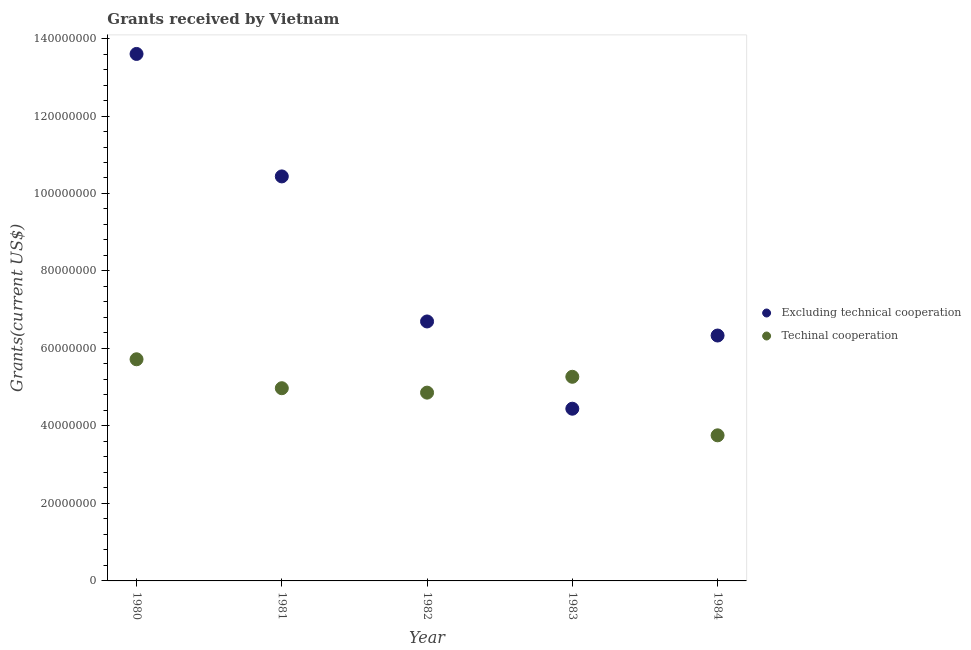Is the number of dotlines equal to the number of legend labels?
Your response must be concise. Yes. What is the amount of grants received(including technical cooperation) in 1983?
Provide a short and direct response. 5.27e+07. Across all years, what is the maximum amount of grants received(including technical cooperation)?
Ensure brevity in your answer.  5.72e+07. Across all years, what is the minimum amount of grants received(including technical cooperation)?
Make the answer very short. 3.76e+07. In which year was the amount of grants received(including technical cooperation) minimum?
Ensure brevity in your answer.  1984. What is the total amount of grants received(including technical cooperation) in the graph?
Keep it short and to the point. 2.46e+08. What is the difference between the amount of grants received(including technical cooperation) in 1981 and that in 1984?
Provide a succinct answer. 1.22e+07. What is the difference between the amount of grants received(including technical cooperation) in 1980 and the amount of grants received(excluding technical cooperation) in 1984?
Ensure brevity in your answer.  -6.13e+06. What is the average amount of grants received(including technical cooperation) per year?
Give a very brief answer. 4.92e+07. In the year 1982, what is the difference between the amount of grants received(including technical cooperation) and amount of grants received(excluding technical cooperation)?
Your answer should be very brief. -1.84e+07. What is the ratio of the amount of grants received(excluding technical cooperation) in 1981 to that in 1984?
Make the answer very short. 1.65. Is the amount of grants received(excluding technical cooperation) in 1980 less than that in 1983?
Offer a terse response. No. Is the difference between the amount of grants received(excluding technical cooperation) in 1982 and 1984 greater than the difference between the amount of grants received(including technical cooperation) in 1982 and 1984?
Your response must be concise. No. What is the difference between the highest and the second highest amount of grants received(excluding technical cooperation)?
Your answer should be very brief. 3.16e+07. What is the difference between the highest and the lowest amount of grants received(including technical cooperation)?
Offer a terse response. 1.96e+07. In how many years, is the amount of grants received(excluding technical cooperation) greater than the average amount of grants received(excluding technical cooperation) taken over all years?
Ensure brevity in your answer.  2. Is the sum of the amount of grants received(excluding technical cooperation) in 1982 and 1983 greater than the maximum amount of grants received(including technical cooperation) across all years?
Your response must be concise. Yes. How many years are there in the graph?
Offer a very short reply. 5. Does the graph contain any zero values?
Provide a succinct answer. No. Does the graph contain grids?
Keep it short and to the point. No. Where does the legend appear in the graph?
Make the answer very short. Center right. How many legend labels are there?
Keep it short and to the point. 2. How are the legend labels stacked?
Keep it short and to the point. Vertical. What is the title of the graph?
Give a very brief answer. Grants received by Vietnam. Does "Overweight" appear as one of the legend labels in the graph?
Ensure brevity in your answer.  No. What is the label or title of the Y-axis?
Provide a short and direct response. Grants(current US$). What is the Grants(current US$) of Excluding technical cooperation in 1980?
Provide a succinct answer. 1.36e+08. What is the Grants(current US$) in Techinal cooperation in 1980?
Offer a very short reply. 5.72e+07. What is the Grants(current US$) of Excluding technical cooperation in 1981?
Give a very brief answer. 1.04e+08. What is the Grants(current US$) of Techinal cooperation in 1981?
Your answer should be very brief. 4.97e+07. What is the Grants(current US$) in Excluding technical cooperation in 1982?
Your answer should be compact. 6.70e+07. What is the Grants(current US$) in Techinal cooperation in 1982?
Ensure brevity in your answer.  4.86e+07. What is the Grants(current US$) in Excluding technical cooperation in 1983?
Make the answer very short. 4.44e+07. What is the Grants(current US$) of Techinal cooperation in 1983?
Offer a terse response. 5.27e+07. What is the Grants(current US$) in Excluding technical cooperation in 1984?
Your answer should be compact. 6.33e+07. What is the Grants(current US$) of Techinal cooperation in 1984?
Keep it short and to the point. 3.76e+07. Across all years, what is the maximum Grants(current US$) of Excluding technical cooperation?
Offer a very short reply. 1.36e+08. Across all years, what is the maximum Grants(current US$) of Techinal cooperation?
Ensure brevity in your answer.  5.72e+07. Across all years, what is the minimum Grants(current US$) of Excluding technical cooperation?
Keep it short and to the point. 4.44e+07. Across all years, what is the minimum Grants(current US$) of Techinal cooperation?
Make the answer very short. 3.76e+07. What is the total Grants(current US$) of Excluding technical cooperation in the graph?
Give a very brief answer. 4.15e+08. What is the total Grants(current US$) of Techinal cooperation in the graph?
Offer a very short reply. 2.46e+08. What is the difference between the Grants(current US$) in Excluding technical cooperation in 1980 and that in 1981?
Offer a very short reply. 3.16e+07. What is the difference between the Grants(current US$) in Techinal cooperation in 1980 and that in 1981?
Ensure brevity in your answer.  7.47e+06. What is the difference between the Grants(current US$) of Excluding technical cooperation in 1980 and that in 1982?
Give a very brief answer. 6.90e+07. What is the difference between the Grants(current US$) of Techinal cooperation in 1980 and that in 1982?
Your answer should be very brief. 8.61e+06. What is the difference between the Grants(current US$) in Excluding technical cooperation in 1980 and that in 1983?
Offer a very short reply. 9.16e+07. What is the difference between the Grants(current US$) of Techinal cooperation in 1980 and that in 1983?
Your response must be concise. 4.52e+06. What is the difference between the Grants(current US$) of Excluding technical cooperation in 1980 and that in 1984?
Your answer should be very brief. 7.27e+07. What is the difference between the Grants(current US$) of Techinal cooperation in 1980 and that in 1984?
Provide a succinct answer. 1.96e+07. What is the difference between the Grants(current US$) of Excluding technical cooperation in 1981 and that in 1982?
Your answer should be compact. 3.74e+07. What is the difference between the Grants(current US$) of Techinal cooperation in 1981 and that in 1982?
Provide a succinct answer. 1.14e+06. What is the difference between the Grants(current US$) in Excluding technical cooperation in 1981 and that in 1983?
Make the answer very short. 6.00e+07. What is the difference between the Grants(current US$) of Techinal cooperation in 1981 and that in 1983?
Ensure brevity in your answer.  -2.95e+06. What is the difference between the Grants(current US$) of Excluding technical cooperation in 1981 and that in 1984?
Your response must be concise. 4.11e+07. What is the difference between the Grants(current US$) in Techinal cooperation in 1981 and that in 1984?
Offer a terse response. 1.22e+07. What is the difference between the Grants(current US$) of Excluding technical cooperation in 1982 and that in 1983?
Provide a short and direct response. 2.25e+07. What is the difference between the Grants(current US$) of Techinal cooperation in 1982 and that in 1983?
Ensure brevity in your answer.  -4.09e+06. What is the difference between the Grants(current US$) of Excluding technical cooperation in 1982 and that in 1984?
Provide a succinct answer. 3.63e+06. What is the difference between the Grants(current US$) in Techinal cooperation in 1982 and that in 1984?
Your answer should be compact. 1.10e+07. What is the difference between the Grants(current US$) of Excluding technical cooperation in 1983 and that in 1984?
Your answer should be very brief. -1.89e+07. What is the difference between the Grants(current US$) of Techinal cooperation in 1983 and that in 1984?
Keep it short and to the point. 1.51e+07. What is the difference between the Grants(current US$) in Excluding technical cooperation in 1980 and the Grants(current US$) in Techinal cooperation in 1981?
Keep it short and to the point. 8.63e+07. What is the difference between the Grants(current US$) in Excluding technical cooperation in 1980 and the Grants(current US$) in Techinal cooperation in 1982?
Keep it short and to the point. 8.74e+07. What is the difference between the Grants(current US$) in Excluding technical cooperation in 1980 and the Grants(current US$) in Techinal cooperation in 1983?
Provide a short and direct response. 8.33e+07. What is the difference between the Grants(current US$) in Excluding technical cooperation in 1980 and the Grants(current US$) in Techinal cooperation in 1984?
Your answer should be compact. 9.84e+07. What is the difference between the Grants(current US$) of Excluding technical cooperation in 1981 and the Grants(current US$) of Techinal cooperation in 1982?
Your answer should be compact. 5.58e+07. What is the difference between the Grants(current US$) of Excluding technical cooperation in 1981 and the Grants(current US$) of Techinal cooperation in 1983?
Provide a succinct answer. 5.17e+07. What is the difference between the Grants(current US$) in Excluding technical cooperation in 1981 and the Grants(current US$) in Techinal cooperation in 1984?
Provide a succinct answer. 6.68e+07. What is the difference between the Grants(current US$) in Excluding technical cooperation in 1982 and the Grants(current US$) in Techinal cooperation in 1983?
Your answer should be compact. 1.43e+07. What is the difference between the Grants(current US$) in Excluding technical cooperation in 1982 and the Grants(current US$) in Techinal cooperation in 1984?
Offer a very short reply. 2.94e+07. What is the difference between the Grants(current US$) of Excluding technical cooperation in 1983 and the Grants(current US$) of Techinal cooperation in 1984?
Offer a terse response. 6.87e+06. What is the average Grants(current US$) of Excluding technical cooperation per year?
Provide a short and direct response. 8.30e+07. What is the average Grants(current US$) in Techinal cooperation per year?
Make the answer very short. 4.92e+07. In the year 1980, what is the difference between the Grants(current US$) in Excluding technical cooperation and Grants(current US$) in Techinal cooperation?
Offer a terse response. 7.88e+07. In the year 1981, what is the difference between the Grants(current US$) in Excluding technical cooperation and Grants(current US$) in Techinal cooperation?
Offer a very short reply. 5.47e+07. In the year 1982, what is the difference between the Grants(current US$) in Excluding technical cooperation and Grants(current US$) in Techinal cooperation?
Give a very brief answer. 1.84e+07. In the year 1983, what is the difference between the Grants(current US$) of Excluding technical cooperation and Grants(current US$) of Techinal cooperation?
Your answer should be very brief. -8.24e+06. In the year 1984, what is the difference between the Grants(current US$) in Excluding technical cooperation and Grants(current US$) in Techinal cooperation?
Keep it short and to the point. 2.58e+07. What is the ratio of the Grants(current US$) in Excluding technical cooperation in 1980 to that in 1981?
Offer a very short reply. 1.3. What is the ratio of the Grants(current US$) of Techinal cooperation in 1980 to that in 1981?
Your answer should be very brief. 1.15. What is the ratio of the Grants(current US$) of Excluding technical cooperation in 1980 to that in 1982?
Keep it short and to the point. 2.03. What is the ratio of the Grants(current US$) in Techinal cooperation in 1980 to that in 1982?
Provide a succinct answer. 1.18. What is the ratio of the Grants(current US$) in Excluding technical cooperation in 1980 to that in 1983?
Make the answer very short. 3.06. What is the ratio of the Grants(current US$) of Techinal cooperation in 1980 to that in 1983?
Provide a short and direct response. 1.09. What is the ratio of the Grants(current US$) of Excluding technical cooperation in 1980 to that in 1984?
Your response must be concise. 2.15. What is the ratio of the Grants(current US$) of Techinal cooperation in 1980 to that in 1984?
Your answer should be very brief. 1.52. What is the ratio of the Grants(current US$) in Excluding technical cooperation in 1981 to that in 1982?
Keep it short and to the point. 1.56. What is the ratio of the Grants(current US$) of Techinal cooperation in 1981 to that in 1982?
Give a very brief answer. 1.02. What is the ratio of the Grants(current US$) of Excluding technical cooperation in 1981 to that in 1983?
Give a very brief answer. 2.35. What is the ratio of the Grants(current US$) of Techinal cooperation in 1981 to that in 1983?
Keep it short and to the point. 0.94. What is the ratio of the Grants(current US$) of Excluding technical cooperation in 1981 to that in 1984?
Your answer should be very brief. 1.65. What is the ratio of the Grants(current US$) of Techinal cooperation in 1981 to that in 1984?
Keep it short and to the point. 1.32. What is the ratio of the Grants(current US$) in Excluding technical cooperation in 1982 to that in 1983?
Keep it short and to the point. 1.51. What is the ratio of the Grants(current US$) in Techinal cooperation in 1982 to that in 1983?
Your response must be concise. 0.92. What is the ratio of the Grants(current US$) in Excluding technical cooperation in 1982 to that in 1984?
Give a very brief answer. 1.06. What is the ratio of the Grants(current US$) of Techinal cooperation in 1982 to that in 1984?
Offer a very short reply. 1.29. What is the ratio of the Grants(current US$) in Excluding technical cooperation in 1983 to that in 1984?
Make the answer very short. 0.7. What is the ratio of the Grants(current US$) in Techinal cooperation in 1983 to that in 1984?
Your answer should be compact. 1.4. What is the difference between the highest and the second highest Grants(current US$) in Excluding technical cooperation?
Offer a very short reply. 3.16e+07. What is the difference between the highest and the second highest Grants(current US$) of Techinal cooperation?
Ensure brevity in your answer.  4.52e+06. What is the difference between the highest and the lowest Grants(current US$) in Excluding technical cooperation?
Your response must be concise. 9.16e+07. What is the difference between the highest and the lowest Grants(current US$) in Techinal cooperation?
Ensure brevity in your answer.  1.96e+07. 